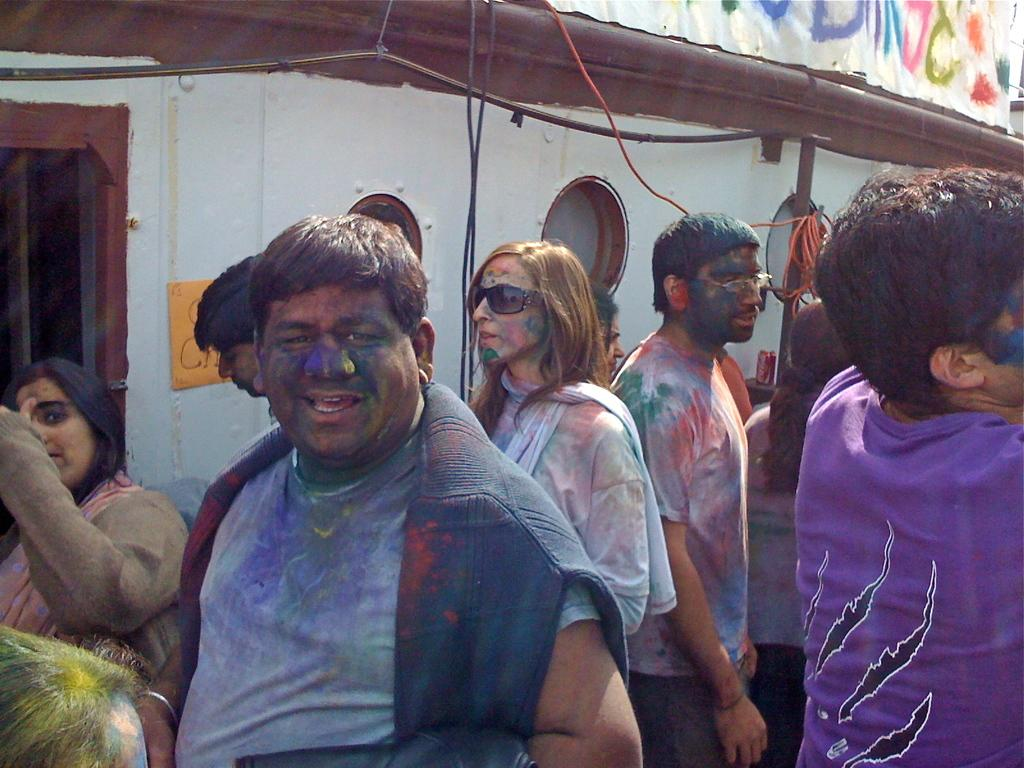How many people are present in the image? There are people in the image, but the exact number is not specified. What can be observed about the people's appearance? The people's faces and clothes are colored. What is visible in the background of the image? There is a wall and cables in the background of the image. Can you describe any text present in the image? There is a text written on an object in the background of the image. How many cattle can be seen grazing in the image? There is no mention of cattle in the image, so it is not possible to determine their presence or number. What type of form is used to write the text on the object in the background? The facts do not provide information about the form or style of the text, so it cannot be determined from the image. 